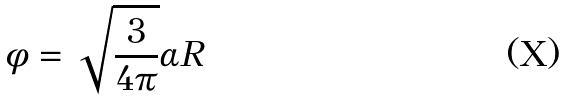<formula> <loc_0><loc_0><loc_500><loc_500>\phi = \sqrt { \frac { 3 } { 4 \pi } } \alpha R</formula> 